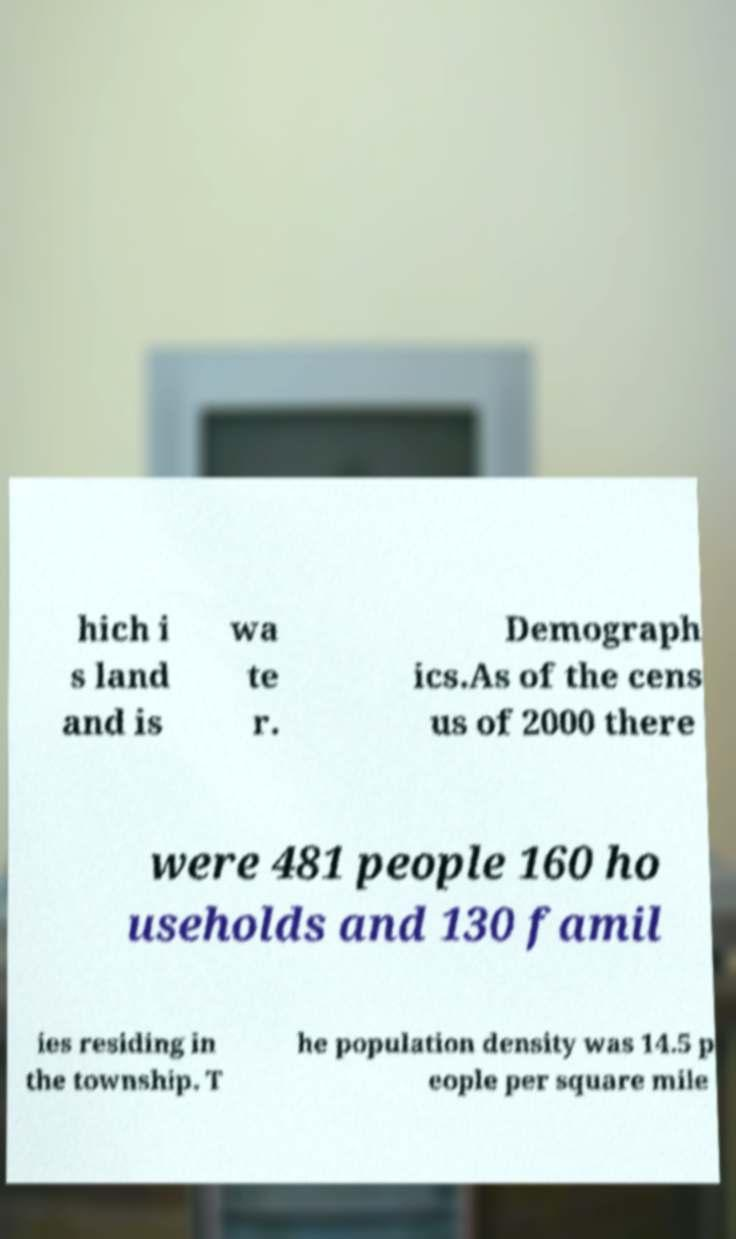Could you assist in decoding the text presented in this image and type it out clearly? hich i s land and is wa te r. Demograph ics.As of the cens us of 2000 there were 481 people 160 ho useholds and 130 famil ies residing in the township. T he population density was 14.5 p eople per square mile 